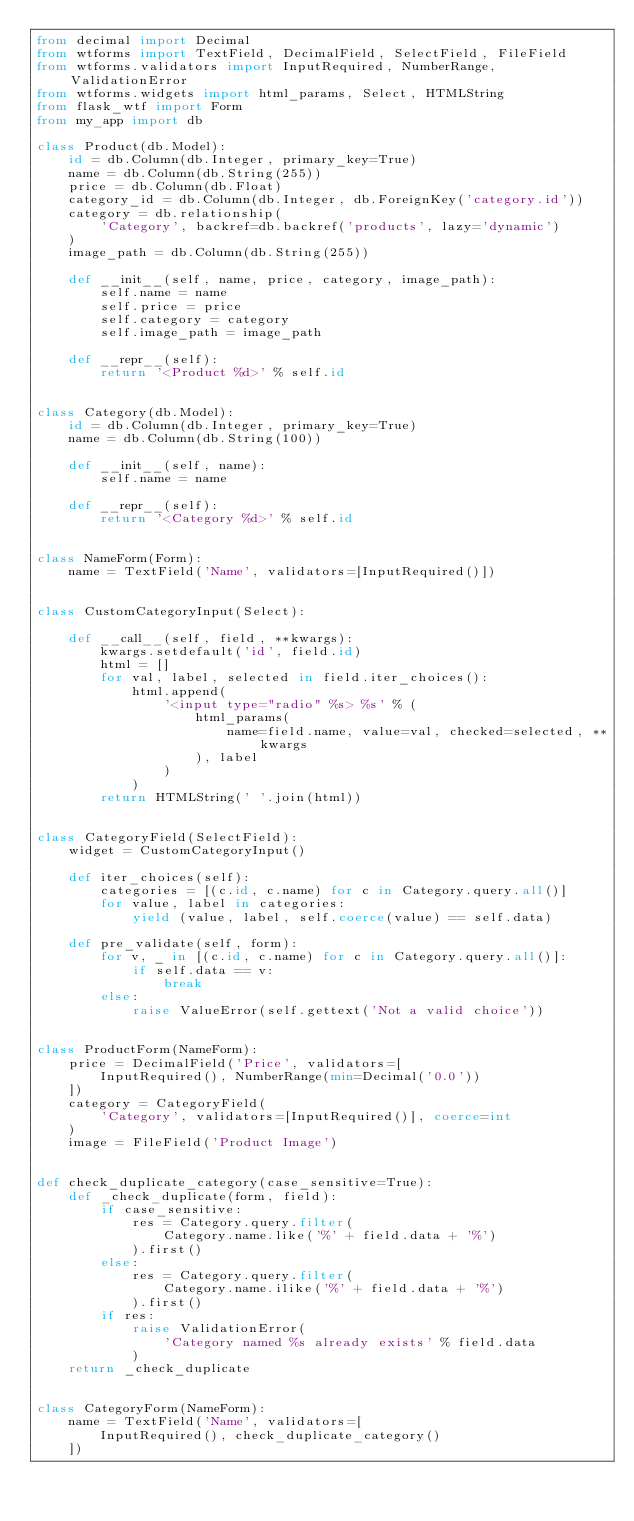Convert code to text. <code><loc_0><loc_0><loc_500><loc_500><_Python_>from decimal import Decimal
from wtforms import TextField, DecimalField, SelectField, FileField
from wtforms.validators import InputRequired, NumberRange, ValidationError
from wtforms.widgets import html_params, Select, HTMLString
from flask_wtf import Form
from my_app import db

class Product(db.Model):
    id = db.Column(db.Integer, primary_key=True)
    name = db.Column(db.String(255))
    price = db.Column(db.Float)
    category_id = db.Column(db.Integer, db.ForeignKey('category.id'))
    category = db.relationship(
        'Category', backref=db.backref('products', lazy='dynamic')
    )
    image_path = db.Column(db.String(255))

    def __init__(self, name, price, category, image_path):
        self.name = name
        self.price = price
        self.category = category
        self.image_path = image_path

    def __repr__(self):
        return '<Product %d>' % self.id


class Category(db.Model):
    id = db.Column(db.Integer, primary_key=True)
    name = db.Column(db.String(100))

    def __init__(self, name):
        self.name = name

    def __repr__(self):
        return '<Category %d>' % self.id


class NameForm(Form):
    name = TextField('Name', validators=[InputRequired()])


class CustomCategoryInput(Select):

    def __call__(self, field, **kwargs):
        kwargs.setdefault('id', field.id)
        html = []
        for val, label, selected in field.iter_choices():
            html.append(
                '<input type="radio" %s> %s' % (
                    html_params(
                        name=field.name, value=val, checked=selected, **kwargs
                    ), label
                )
            )
        return HTMLString(' '.join(html))


class CategoryField(SelectField):
    widget = CustomCategoryInput()

    def iter_choices(self):
        categories = [(c.id, c.name) for c in Category.query.all()]
        for value, label in categories:
            yield (value, label, self.coerce(value) == self.data)

    def pre_validate(self, form):
        for v, _ in [(c.id, c.name) for c in Category.query.all()]:
            if self.data == v:
                break
        else:
            raise ValueError(self.gettext('Not a valid choice'))


class ProductForm(NameForm):
    price = DecimalField('Price', validators=[
        InputRequired(), NumberRange(min=Decimal('0.0'))
    ])
    category = CategoryField(
        'Category', validators=[InputRequired()], coerce=int
    )
    image = FileField('Product Image')


def check_duplicate_category(case_sensitive=True):
    def _check_duplicate(form, field):
        if case_sensitive:
            res = Category.query.filter(
                Category.name.like('%' + field.data + '%')
            ).first()
        else:
            res = Category.query.filter(
                Category.name.ilike('%' + field.data + '%')
            ).first()
        if res:
            raise ValidationError(
                'Category named %s already exists' % field.data
            )
    return _check_duplicate


class CategoryForm(NameForm):
    name = TextField('Name', validators=[
        InputRequired(), check_duplicate_category()
    ])
</code> 